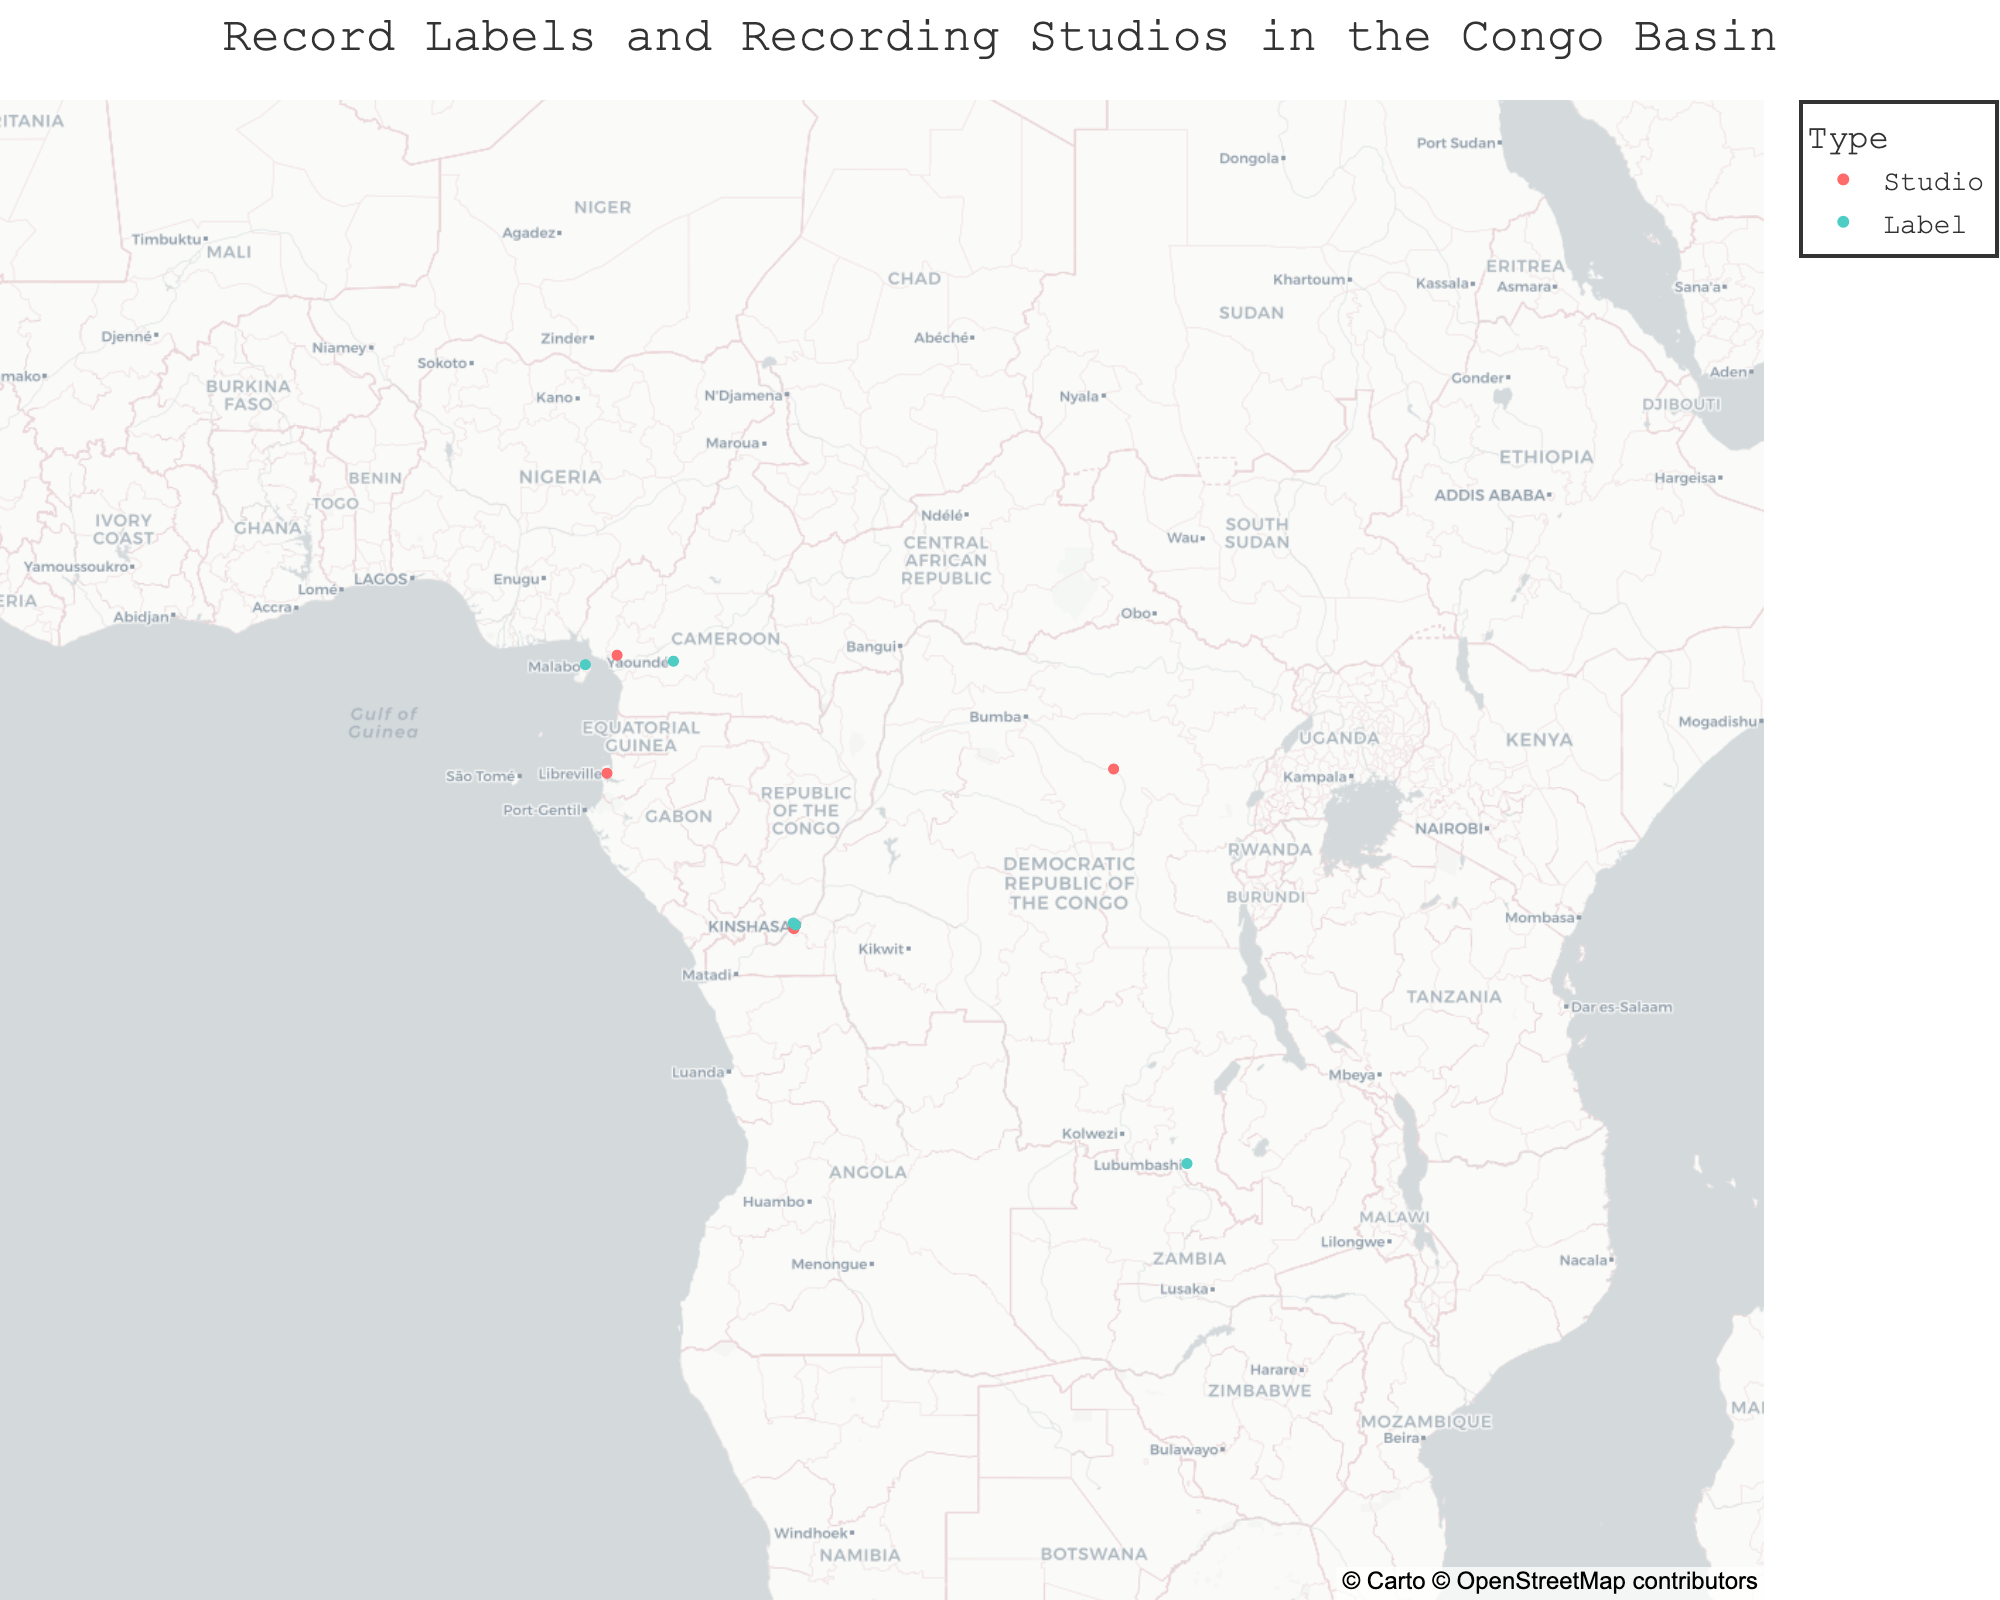What's the title of the plot? The title is typically located at the top center of the plot. It often provides a summary of what the plot depicts.
Answer: Record Labels and Recording Studios in the Congo Basin How many total recording studios are shown in the plot? Count the number of data points categorized as "Studio" on the plot.
Answer: 5 Which city has the highest number of data points? Identify the city that appears most frequently in the plot annotations.
Answer: Kinshasa What is the latitude and longitude of Yaoundé Records? Look for the data point labeled "Yaoundé Records" and note its latitude and longitude coordinates from the plot.
Answer: Latitude: 3.8667, Longitude: 11.5167 Are there more labels or studios in Kinshasa? Count the number of "Label" and "Studio" data points in Kinshasa by the annotations or color coding. Compare the counts.
Answer: More studios Which countries have both record labels and recording studios represented? Identify the countries from the data points and check if they have both "Label" and "Studio" categories.
Answer: Democratic Republic of the Congo and Cameroon How many recording studios are there in countries outside the Democratic Republic of the Congo? Count the "Studio" data points located outside the boundaries of the Democratic Republic of the Congo using the provided geographic information.
Answer: 2 Which type of data point is more common in the plot? Count the total number of "Label" and "Studio" data points and compare their counts.
Answer: Labels What's the farthest distance between any two data points on the plot? Measure the geographic distance between the two data points that are furthest apart (e.g., Lubumbashi Grooves and Malabo Melodies, considering the coordinates). Use the Haversine formula to calculate the distance.
Answer: Approximately 3,680 km Which city has only one type of data point, and what is it? Identify cities with only either "Label" or "Studio" data points by inspecting the annotations on the plot.
Answer: Kisangani, Studio 